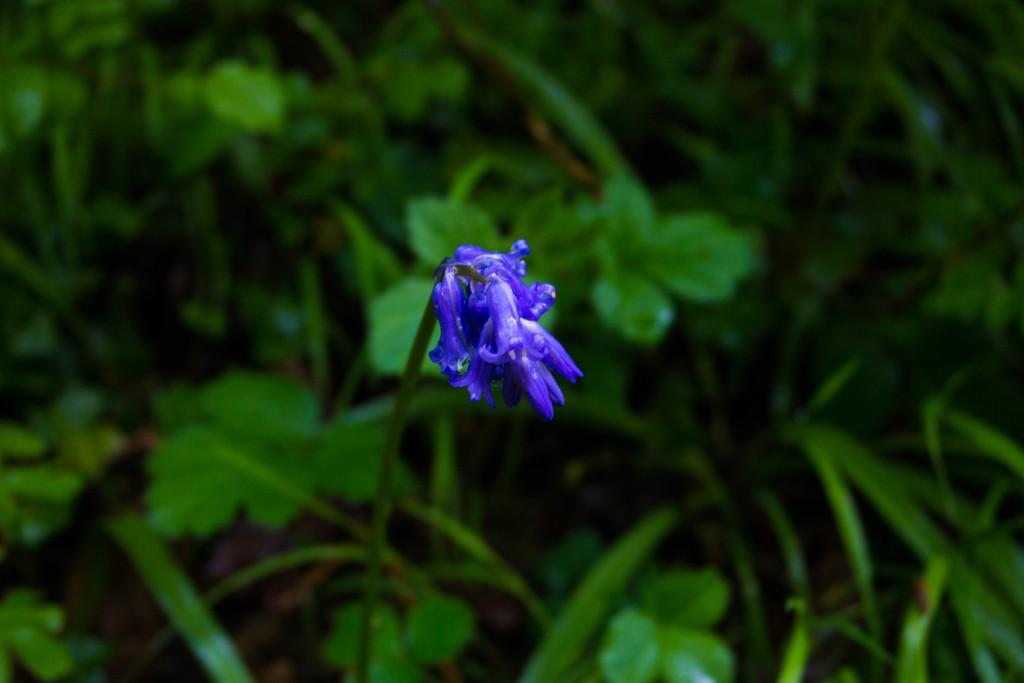What type of living organisms can be seen in the image? Plants and a flower are visible in the image. Can you describe the flower in the image? The flower is a part of the plants in the image. What is the tendency of the wind in the image? There is no mention of wind in the image, so it is not possible to determine its tendency. 